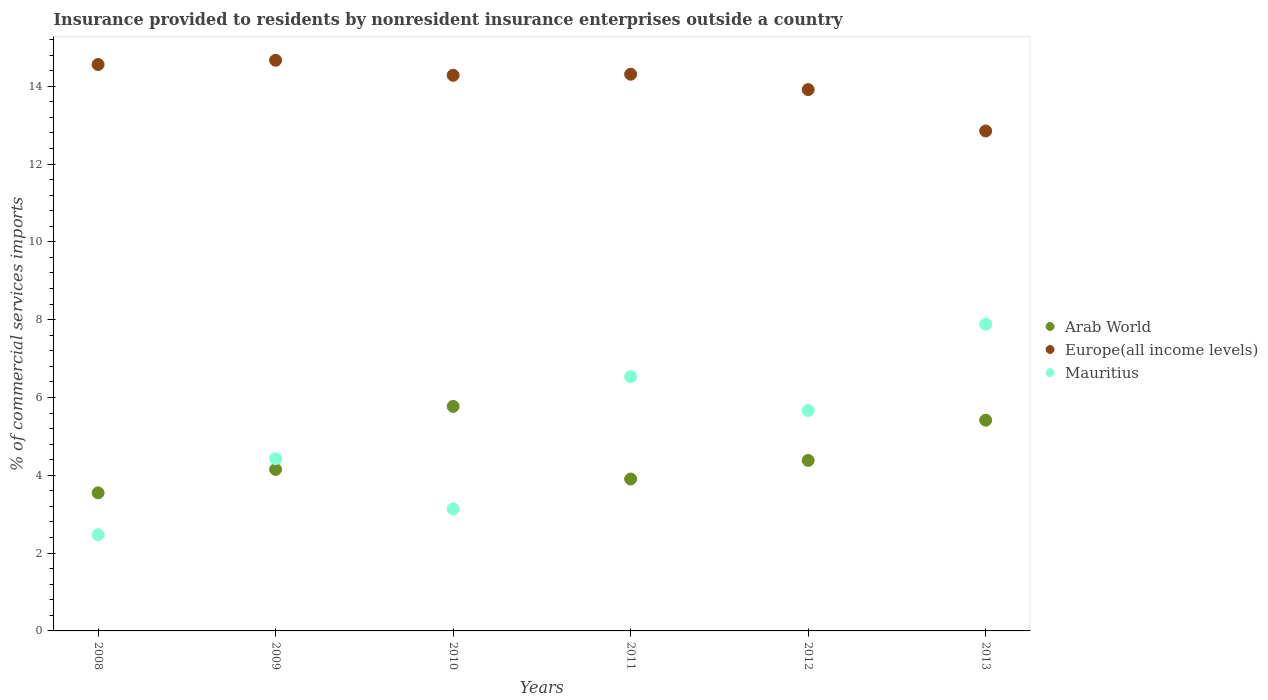Is the number of dotlines equal to the number of legend labels?
Ensure brevity in your answer.  Yes. What is the Insurance provided to residents in Europe(all income levels) in 2009?
Make the answer very short. 14.67. Across all years, what is the maximum Insurance provided to residents in Mauritius?
Your response must be concise. 7.88. Across all years, what is the minimum Insurance provided to residents in Mauritius?
Your answer should be very brief. 2.47. In which year was the Insurance provided to residents in Europe(all income levels) maximum?
Your response must be concise. 2009. What is the total Insurance provided to residents in Mauritius in the graph?
Make the answer very short. 30.12. What is the difference between the Insurance provided to residents in Arab World in 2011 and that in 2013?
Offer a terse response. -1.51. What is the difference between the Insurance provided to residents in Europe(all income levels) in 2011 and the Insurance provided to residents in Arab World in 2010?
Your answer should be very brief. 8.54. What is the average Insurance provided to residents in Europe(all income levels) per year?
Provide a succinct answer. 14.1. In the year 2011, what is the difference between the Insurance provided to residents in Mauritius and Insurance provided to residents in Europe(all income levels)?
Provide a succinct answer. -7.78. What is the ratio of the Insurance provided to residents in Arab World in 2009 to that in 2013?
Your answer should be very brief. 0.77. Is the Insurance provided to residents in Mauritius in 2012 less than that in 2013?
Your response must be concise. Yes. Is the difference between the Insurance provided to residents in Mauritius in 2009 and 2011 greater than the difference between the Insurance provided to residents in Europe(all income levels) in 2009 and 2011?
Your answer should be very brief. No. What is the difference between the highest and the second highest Insurance provided to residents in Mauritius?
Provide a short and direct response. 1.35. What is the difference between the highest and the lowest Insurance provided to residents in Europe(all income levels)?
Provide a succinct answer. 1.82. Is the sum of the Insurance provided to residents in Mauritius in 2009 and 2013 greater than the maximum Insurance provided to residents in Europe(all income levels) across all years?
Keep it short and to the point. No. Does the Insurance provided to residents in Mauritius monotonically increase over the years?
Give a very brief answer. No. Is the Insurance provided to residents in Europe(all income levels) strictly less than the Insurance provided to residents in Mauritius over the years?
Give a very brief answer. No. How many dotlines are there?
Give a very brief answer. 3. How many years are there in the graph?
Your response must be concise. 6. What is the difference between two consecutive major ticks on the Y-axis?
Ensure brevity in your answer.  2. Are the values on the major ticks of Y-axis written in scientific E-notation?
Offer a terse response. No. Does the graph contain grids?
Make the answer very short. No. How many legend labels are there?
Keep it short and to the point. 3. How are the legend labels stacked?
Keep it short and to the point. Vertical. What is the title of the graph?
Make the answer very short. Insurance provided to residents by nonresident insurance enterprises outside a country. What is the label or title of the X-axis?
Provide a short and direct response. Years. What is the label or title of the Y-axis?
Offer a very short reply. % of commercial services imports. What is the % of commercial services imports in Arab World in 2008?
Make the answer very short. 3.55. What is the % of commercial services imports of Europe(all income levels) in 2008?
Your answer should be compact. 14.56. What is the % of commercial services imports in Mauritius in 2008?
Make the answer very short. 2.47. What is the % of commercial services imports of Arab World in 2009?
Offer a terse response. 4.15. What is the % of commercial services imports in Europe(all income levels) in 2009?
Offer a terse response. 14.67. What is the % of commercial services imports in Mauritius in 2009?
Your answer should be very brief. 4.43. What is the % of commercial services imports in Arab World in 2010?
Your answer should be compact. 5.77. What is the % of commercial services imports of Europe(all income levels) in 2010?
Your answer should be compact. 14.28. What is the % of commercial services imports of Mauritius in 2010?
Offer a terse response. 3.14. What is the % of commercial services imports of Arab World in 2011?
Keep it short and to the point. 3.9. What is the % of commercial services imports of Europe(all income levels) in 2011?
Offer a terse response. 14.31. What is the % of commercial services imports in Mauritius in 2011?
Offer a very short reply. 6.53. What is the % of commercial services imports in Arab World in 2012?
Provide a short and direct response. 4.38. What is the % of commercial services imports in Europe(all income levels) in 2012?
Offer a terse response. 13.91. What is the % of commercial services imports in Mauritius in 2012?
Make the answer very short. 5.67. What is the % of commercial services imports in Arab World in 2013?
Ensure brevity in your answer.  5.42. What is the % of commercial services imports of Europe(all income levels) in 2013?
Offer a very short reply. 12.85. What is the % of commercial services imports in Mauritius in 2013?
Offer a very short reply. 7.88. Across all years, what is the maximum % of commercial services imports of Arab World?
Offer a very short reply. 5.77. Across all years, what is the maximum % of commercial services imports in Europe(all income levels)?
Offer a terse response. 14.67. Across all years, what is the maximum % of commercial services imports in Mauritius?
Give a very brief answer. 7.88. Across all years, what is the minimum % of commercial services imports of Arab World?
Provide a succinct answer. 3.55. Across all years, what is the minimum % of commercial services imports in Europe(all income levels)?
Offer a very short reply. 12.85. Across all years, what is the minimum % of commercial services imports of Mauritius?
Your answer should be compact. 2.47. What is the total % of commercial services imports of Arab World in the graph?
Make the answer very short. 27.17. What is the total % of commercial services imports in Europe(all income levels) in the graph?
Provide a succinct answer. 84.58. What is the total % of commercial services imports of Mauritius in the graph?
Provide a succinct answer. 30.12. What is the difference between the % of commercial services imports of Arab World in 2008 and that in 2009?
Provide a short and direct response. -0.6. What is the difference between the % of commercial services imports of Europe(all income levels) in 2008 and that in 2009?
Give a very brief answer. -0.11. What is the difference between the % of commercial services imports in Mauritius in 2008 and that in 2009?
Make the answer very short. -1.96. What is the difference between the % of commercial services imports of Arab World in 2008 and that in 2010?
Ensure brevity in your answer.  -2.22. What is the difference between the % of commercial services imports of Europe(all income levels) in 2008 and that in 2010?
Offer a terse response. 0.28. What is the difference between the % of commercial services imports in Mauritius in 2008 and that in 2010?
Give a very brief answer. -0.67. What is the difference between the % of commercial services imports of Arab World in 2008 and that in 2011?
Give a very brief answer. -0.36. What is the difference between the % of commercial services imports in Europe(all income levels) in 2008 and that in 2011?
Give a very brief answer. 0.25. What is the difference between the % of commercial services imports in Mauritius in 2008 and that in 2011?
Ensure brevity in your answer.  -4.06. What is the difference between the % of commercial services imports of Arab World in 2008 and that in 2012?
Offer a very short reply. -0.83. What is the difference between the % of commercial services imports in Europe(all income levels) in 2008 and that in 2012?
Make the answer very short. 0.65. What is the difference between the % of commercial services imports of Mauritius in 2008 and that in 2012?
Give a very brief answer. -3.2. What is the difference between the % of commercial services imports of Arab World in 2008 and that in 2013?
Provide a short and direct response. -1.87. What is the difference between the % of commercial services imports of Europe(all income levels) in 2008 and that in 2013?
Give a very brief answer. 1.71. What is the difference between the % of commercial services imports in Mauritius in 2008 and that in 2013?
Your answer should be compact. -5.41. What is the difference between the % of commercial services imports in Arab World in 2009 and that in 2010?
Offer a very short reply. -1.62. What is the difference between the % of commercial services imports in Europe(all income levels) in 2009 and that in 2010?
Give a very brief answer. 0.39. What is the difference between the % of commercial services imports of Mauritius in 2009 and that in 2010?
Offer a very short reply. 1.29. What is the difference between the % of commercial services imports of Arab World in 2009 and that in 2011?
Give a very brief answer. 0.25. What is the difference between the % of commercial services imports in Europe(all income levels) in 2009 and that in 2011?
Offer a terse response. 0.36. What is the difference between the % of commercial services imports of Mauritius in 2009 and that in 2011?
Your answer should be compact. -2.11. What is the difference between the % of commercial services imports of Arab World in 2009 and that in 2012?
Ensure brevity in your answer.  -0.23. What is the difference between the % of commercial services imports of Europe(all income levels) in 2009 and that in 2012?
Your answer should be compact. 0.75. What is the difference between the % of commercial services imports in Mauritius in 2009 and that in 2012?
Give a very brief answer. -1.24. What is the difference between the % of commercial services imports in Arab World in 2009 and that in 2013?
Your response must be concise. -1.27. What is the difference between the % of commercial services imports in Europe(all income levels) in 2009 and that in 2013?
Provide a succinct answer. 1.82. What is the difference between the % of commercial services imports in Mauritius in 2009 and that in 2013?
Make the answer very short. -3.46. What is the difference between the % of commercial services imports in Arab World in 2010 and that in 2011?
Provide a short and direct response. 1.87. What is the difference between the % of commercial services imports of Europe(all income levels) in 2010 and that in 2011?
Provide a short and direct response. -0.03. What is the difference between the % of commercial services imports in Mauritius in 2010 and that in 2011?
Your response must be concise. -3.4. What is the difference between the % of commercial services imports of Arab World in 2010 and that in 2012?
Keep it short and to the point. 1.39. What is the difference between the % of commercial services imports in Europe(all income levels) in 2010 and that in 2012?
Offer a terse response. 0.37. What is the difference between the % of commercial services imports of Mauritius in 2010 and that in 2012?
Ensure brevity in your answer.  -2.53. What is the difference between the % of commercial services imports in Arab World in 2010 and that in 2013?
Your answer should be compact. 0.35. What is the difference between the % of commercial services imports of Europe(all income levels) in 2010 and that in 2013?
Keep it short and to the point. 1.43. What is the difference between the % of commercial services imports of Mauritius in 2010 and that in 2013?
Make the answer very short. -4.75. What is the difference between the % of commercial services imports in Arab World in 2011 and that in 2012?
Provide a short and direct response. -0.48. What is the difference between the % of commercial services imports in Europe(all income levels) in 2011 and that in 2012?
Ensure brevity in your answer.  0.4. What is the difference between the % of commercial services imports in Mauritius in 2011 and that in 2012?
Keep it short and to the point. 0.87. What is the difference between the % of commercial services imports in Arab World in 2011 and that in 2013?
Keep it short and to the point. -1.51. What is the difference between the % of commercial services imports of Europe(all income levels) in 2011 and that in 2013?
Ensure brevity in your answer.  1.46. What is the difference between the % of commercial services imports in Mauritius in 2011 and that in 2013?
Offer a terse response. -1.35. What is the difference between the % of commercial services imports of Arab World in 2012 and that in 2013?
Keep it short and to the point. -1.03. What is the difference between the % of commercial services imports of Europe(all income levels) in 2012 and that in 2013?
Provide a short and direct response. 1.06. What is the difference between the % of commercial services imports in Mauritius in 2012 and that in 2013?
Give a very brief answer. -2.22. What is the difference between the % of commercial services imports of Arab World in 2008 and the % of commercial services imports of Europe(all income levels) in 2009?
Your answer should be very brief. -11.12. What is the difference between the % of commercial services imports in Arab World in 2008 and the % of commercial services imports in Mauritius in 2009?
Give a very brief answer. -0.88. What is the difference between the % of commercial services imports of Europe(all income levels) in 2008 and the % of commercial services imports of Mauritius in 2009?
Give a very brief answer. 10.13. What is the difference between the % of commercial services imports of Arab World in 2008 and the % of commercial services imports of Europe(all income levels) in 2010?
Give a very brief answer. -10.73. What is the difference between the % of commercial services imports of Arab World in 2008 and the % of commercial services imports of Mauritius in 2010?
Ensure brevity in your answer.  0.41. What is the difference between the % of commercial services imports of Europe(all income levels) in 2008 and the % of commercial services imports of Mauritius in 2010?
Offer a terse response. 11.42. What is the difference between the % of commercial services imports of Arab World in 2008 and the % of commercial services imports of Europe(all income levels) in 2011?
Ensure brevity in your answer.  -10.76. What is the difference between the % of commercial services imports in Arab World in 2008 and the % of commercial services imports in Mauritius in 2011?
Provide a succinct answer. -2.98. What is the difference between the % of commercial services imports of Europe(all income levels) in 2008 and the % of commercial services imports of Mauritius in 2011?
Provide a short and direct response. 8.03. What is the difference between the % of commercial services imports of Arab World in 2008 and the % of commercial services imports of Europe(all income levels) in 2012?
Ensure brevity in your answer.  -10.36. What is the difference between the % of commercial services imports in Arab World in 2008 and the % of commercial services imports in Mauritius in 2012?
Make the answer very short. -2.12. What is the difference between the % of commercial services imports of Europe(all income levels) in 2008 and the % of commercial services imports of Mauritius in 2012?
Your answer should be compact. 8.89. What is the difference between the % of commercial services imports in Arab World in 2008 and the % of commercial services imports in Europe(all income levels) in 2013?
Make the answer very short. -9.3. What is the difference between the % of commercial services imports in Arab World in 2008 and the % of commercial services imports in Mauritius in 2013?
Ensure brevity in your answer.  -4.33. What is the difference between the % of commercial services imports of Europe(all income levels) in 2008 and the % of commercial services imports of Mauritius in 2013?
Offer a very short reply. 6.68. What is the difference between the % of commercial services imports of Arab World in 2009 and the % of commercial services imports of Europe(all income levels) in 2010?
Provide a short and direct response. -10.13. What is the difference between the % of commercial services imports of Arab World in 2009 and the % of commercial services imports of Mauritius in 2010?
Your answer should be very brief. 1.01. What is the difference between the % of commercial services imports of Europe(all income levels) in 2009 and the % of commercial services imports of Mauritius in 2010?
Provide a succinct answer. 11.53. What is the difference between the % of commercial services imports of Arab World in 2009 and the % of commercial services imports of Europe(all income levels) in 2011?
Make the answer very short. -10.16. What is the difference between the % of commercial services imports in Arab World in 2009 and the % of commercial services imports in Mauritius in 2011?
Your response must be concise. -2.38. What is the difference between the % of commercial services imports in Europe(all income levels) in 2009 and the % of commercial services imports in Mauritius in 2011?
Provide a short and direct response. 8.13. What is the difference between the % of commercial services imports of Arab World in 2009 and the % of commercial services imports of Europe(all income levels) in 2012?
Give a very brief answer. -9.76. What is the difference between the % of commercial services imports of Arab World in 2009 and the % of commercial services imports of Mauritius in 2012?
Your answer should be compact. -1.52. What is the difference between the % of commercial services imports in Europe(all income levels) in 2009 and the % of commercial services imports in Mauritius in 2012?
Offer a very short reply. 9. What is the difference between the % of commercial services imports of Arab World in 2009 and the % of commercial services imports of Europe(all income levels) in 2013?
Provide a succinct answer. -8.7. What is the difference between the % of commercial services imports in Arab World in 2009 and the % of commercial services imports in Mauritius in 2013?
Ensure brevity in your answer.  -3.73. What is the difference between the % of commercial services imports in Europe(all income levels) in 2009 and the % of commercial services imports in Mauritius in 2013?
Give a very brief answer. 6.78. What is the difference between the % of commercial services imports of Arab World in 2010 and the % of commercial services imports of Europe(all income levels) in 2011?
Keep it short and to the point. -8.54. What is the difference between the % of commercial services imports of Arab World in 2010 and the % of commercial services imports of Mauritius in 2011?
Give a very brief answer. -0.76. What is the difference between the % of commercial services imports of Europe(all income levels) in 2010 and the % of commercial services imports of Mauritius in 2011?
Provide a short and direct response. 7.75. What is the difference between the % of commercial services imports of Arab World in 2010 and the % of commercial services imports of Europe(all income levels) in 2012?
Your response must be concise. -8.14. What is the difference between the % of commercial services imports of Arab World in 2010 and the % of commercial services imports of Mauritius in 2012?
Ensure brevity in your answer.  0.1. What is the difference between the % of commercial services imports of Europe(all income levels) in 2010 and the % of commercial services imports of Mauritius in 2012?
Provide a succinct answer. 8.62. What is the difference between the % of commercial services imports in Arab World in 2010 and the % of commercial services imports in Europe(all income levels) in 2013?
Make the answer very short. -7.08. What is the difference between the % of commercial services imports in Arab World in 2010 and the % of commercial services imports in Mauritius in 2013?
Provide a succinct answer. -2.11. What is the difference between the % of commercial services imports in Europe(all income levels) in 2010 and the % of commercial services imports in Mauritius in 2013?
Keep it short and to the point. 6.4. What is the difference between the % of commercial services imports of Arab World in 2011 and the % of commercial services imports of Europe(all income levels) in 2012?
Offer a terse response. -10.01. What is the difference between the % of commercial services imports in Arab World in 2011 and the % of commercial services imports in Mauritius in 2012?
Your answer should be compact. -1.76. What is the difference between the % of commercial services imports in Europe(all income levels) in 2011 and the % of commercial services imports in Mauritius in 2012?
Your response must be concise. 8.64. What is the difference between the % of commercial services imports of Arab World in 2011 and the % of commercial services imports of Europe(all income levels) in 2013?
Keep it short and to the point. -8.95. What is the difference between the % of commercial services imports of Arab World in 2011 and the % of commercial services imports of Mauritius in 2013?
Keep it short and to the point. -3.98. What is the difference between the % of commercial services imports of Europe(all income levels) in 2011 and the % of commercial services imports of Mauritius in 2013?
Offer a terse response. 6.43. What is the difference between the % of commercial services imports of Arab World in 2012 and the % of commercial services imports of Europe(all income levels) in 2013?
Your answer should be very brief. -8.47. What is the difference between the % of commercial services imports in Arab World in 2012 and the % of commercial services imports in Mauritius in 2013?
Offer a terse response. -3.5. What is the difference between the % of commercial services imports of Europe(all income levels) in 2012 and the % of commercial services imports of Mauritius in 2013?
Your answer should be compact. 6.03. What is the average % of commercial services imports in Arab World per year?
Your answer should be very brief. 4.53. What is the average % of commercial services imports in Europe(all income levels) per year?
Your response must be concise. 14.1. What is the average % of commercial services imports in Mauritius per year?
Your answer should be compact. 5.02. In the year 2008, what is the difference between the % of commercial services imports of Arab World and % of commercial services imports of Europe(all income levels)?
Your answer should be compact. -11.01. In the year 2008, what is the difference between the % of commercial services imports of Arab World and % of commercial services imports of Mauritius?
Your answer should be very brief. 1.08. In the year 2008, what is the difference between the % of commercial services imports in Europe(all income levels) and % of commercial services imports in Mauritius?
Your response must be concise. 12.09. In the year 2009, what is the difference between the % of commercial services imports of Arab World and % of commercial services imports of Europe(all income levels)?
Give a very brief answer. -10.52. In the year 2009, what is the difference between the % of commercial services imports of Arab World and % of commercial services imports of Mauritius?
Your answer should be very brief. -0.28. In the year 2009, what is the difference between the % of commercial services imports of Europe(all income levels) and % of commercial services imports of Mauritius?
Provide a succinct answer. 10.24. In the year 2010, what is the difference between the % of commercial services imports of Arab World and % of commercial services imports of Europe(all income levels)?
Keep it short and to the point. -8.51. In the year 2010, what is the difference between the % of commercial services imports of Arab World and % of commercial services imports of Mauritius?
Ensure brevity in your answer.  2.63. In the year 2010, what is the difference between the % of commercial services imports in Europe(all income levels) and % of commercial services imports in Mauritius?
Your response must be concise. 11.14. In the year 2011, what is the difference between the % of commercial services imports of Arab World and % of commercial services imports of Europe(all income levels)?
Offer a very short reply. -10.4. In the year 2011, what is the difference between the % of commercial services imports in Arab World and % of commercial services imports in Mauritius?
Your response must be concise. -2.63. In the year 2011, what is the difference between the % of commercial services imports of Europe(all income levels) and % of commercial services imports of Mauritius?
Keep it short and to the point. 7.78. In the year 2012, what is the difference between the % of commercial services imports in Arab World and % of commercial services imports in Europe(all income levels)?
Provide a succinct answer. -9.53. In the year 2012, what is the difference between the % of commercial services imports in Arab World and % of commercial services imports in Mauritius?
Make the answer very short. -1.28. In the year 2012, what is the difference between the % of commercial services imports in Europe(all income levels) and % of commercial services imports in Mauritius?
Keep it short and to the point. 8.25. In the year 2013, what is the difference between the % of commercial services imports of Arab World and % of commercial services imports of Europe(all income levels)?
Your answer should be very brief. -7.43. In the year 2013, what is the difference between the % of commercial services imports in Arab World and % of commercial services imports in Mauritius?
Your answer should be compact. -2.47. In the year 2013, what is the difference between the % of commercial services imports in Europe(all income levels) and % of commercial services imports in Mauritius?
Give a very brief answer. 4.97. What is the ratio of the % of commercial services imports of Arab World in 2008 to that in 2009?
Provide a short and direct response. 0.86. What is the ratio of the % of commercial services imports in Mauritius in 2008 to that in 2009?
Provide a succinct answer. 0.56. What is the ratio of the % of commercial services imports of Arab World in 2008 to that in 2010?
Make the answer very short. 0.62. What is the ratio of the % of commercial services imports of Europe(all income levels) in 2008 to that in 2010?
Your response must be concise. 1.02. What is the ratio of the % of commercial services imports of Mauritius in 2008 to that in 2010?
Keep it short and to the point. 0.79. What is the ratio of the % of commercial services imports of Europe(all income levels) in 2008 to that in 2011?
Ensure brevity in your answer.  1.02. What is the ratio of the % of commercial services imports in Mauritius in 2008 to that in 2011?
Your answer should be very brief. 0.38. What is the ratio of the % of commercial services imports in Arab World in 2008 to that in 2012?
Keep it short and to the point. 0.81. What is the ratio of the % of commercial services imports of Europe(all income levels) in 2008 to that in 2012?
Offer a very short reply. 1.05. What is the ratio of the % of commercial services imports in Mauritius in 2008 to that in 2012?
Your answer should be compact. 0.44. What is the ratio of the % of commercial services imports of Arab World in 2008 to that in 2013?
Offer a terse response. 0.66. What is the ratio of the % of commercial services imports in Europe(all income levels) in 2008 to that in 2013?
Offer a very short reply. 1.13. What is the ratio of the % of commercial services imports in Mauritius in 2008 to that in 2013?
Keep it short and to the point. 0.31. What is the ratio of the % of commercial services imports in Arab World in 2009 to that in 2010?
Your answer should be very brief. 0.72. What is the ratio of the % of commercial services imports of Europe(all income levels) in 2009 to that in 2010?
Your answer should be compact. 1.03. What is the ratio of the % of commercial services imports of Mauritius in 2009 to that in 2010?
Offer a very short reply. 1.41. What is the ratio of the % of commercial services imports of Arab World in 2009 to that in 2011?
Provide a succinct answer. 1.06. What is the ratio of the % of commercial services imports in Europe(all income levels) in 2009 to that in 2011?
Offer a terse response. 1.02. What is the ratio of the % of commercial services imports of Mauritius in 2009 to that in 2011?
Give a very brief answer. 0.68. What is the ratio of the % of commercial services imports of Arab World in 2009 to that in 2012?
Provide a succinct answer. 0.95. What is the ratio of the % of commercial services imports in Europe(all income levels) in 2009 to that in 2012?
Provide a short and direct response. 1.05. What is the ratio of the % of commercial services imports of Mauritius in 2009 to that in 2012?
Your answer should be very brief. 0.78. What is the ratio of the % of commercial services imports in Arab World in 2009 to that in 2013?
Offer a terse response. 0.77. What is the ratio of the % of commercial services imports in Europe(all income levels) in 2009 to that in 2013?
Your answer should be compact. 1.14. What is the ratio of the % of commercial services imports in Mauritius in 2009 to that in 2013?
Your response must be concise. 0.56. What is the ratio of the % of commercial services imports in Arab World in 2010 to that in 2011?
Keep it short and to the point. 1.48. What is the ratio of the % of commercial services imports of Europe(all income levels) in 2010 to that in 2011?
Make the answer very short. 1. What is the ratio of the % of commercial services imports of Mauritius in 2010 to that in 2011?
Ensure brevity in your answer.  0.48. What is the ratio of the % of commercial services imports of Arab World in 2010 to that in 2012?
Your answer should be compact. 1.32. What is the ratio of the % of commercial services imports in Europe(all income levels) in 2010 to that in 2012?
Your response must be concise. 1.03. What is the ratio of the % of commercial services imports of Mauritius in 2010 to that in 2012?
Ensure brevity in your answer.  0.55. What is the ratio of the % of commercial services imports in Arab World in 2010 to that in 2013?
Make the answer very short. 1.07. What is the ratio of the % of commercial services imports of Europe(all income levels) in 2010 to that in 2013?
Give a very brief answer. 1.11. What is the ratio of the % of commercial services imports of Mauritius in 2010 to that in 2013?
Provide a short and direct response. 0.4. What is the ratio of the % of commercial services imports in Arab World in 2011 to that in 2012?
Give a very brief answer. 0.89. What is the ratio of the % of commercial services imports of Europe(all income levels) in 2011 to that in 2012?
Offer a terse response. 1.03. What is the ratio of the % of commercial services imports in Mauritius in 2011 to that in 2012?
Ensure brevity in your answer.  1.15. What is the ratio of the % of commercial services imports in Arab World in 2011 to that in 2013?
Keep it short and to the point. 0.72. What is the ratio of the % of commercial services imports of Europe(all income levels) in 2011 to that in 2013?
Ensure brevity in your answer.  1.11. What is the ratio of the % of commercial services imports of Mauritius in 2011 to that in 2013?
Provide a succinct answer. 0.83. What is the ratio of the % of commercial services imports of Arab World in 2012 to that in 2013?
Your answer should be very brief. 0.81. What is the ratio of the % of commercial services imports in Europe(all income levels) in 2012 to that in 2013?
Make the answer very short. 1.08. What is the ratio of the % of commercial services imports in Mauritius in 2012 to that in 2013?
Give a very brief answer. 0.72. What is the difference between the highest and the second highest % of commercial services imports of Arab World?
Offer a terse response. 0.35. What is the difference between the highest and the second highest % of commercial services imports in Europe(all income levels)?
Offer a very short reply. 0.11. What is the difference between the highest and the second highest % of commercial services imports in Mauritius?
Your answer should be compact. 1.35. What is the difference between the highest and the lowest % of commercial services imports in Arab World?
Your response must be concise. 2.22. What is the difference between the highest and the lowest % of commercial services imports in Europe(all income levels)?
Your answer should be very brief. 1.82. What is the difference between the highest and the lowest % of commercial services imports of Mauritius?
Offer a very short reply. 5.41. 